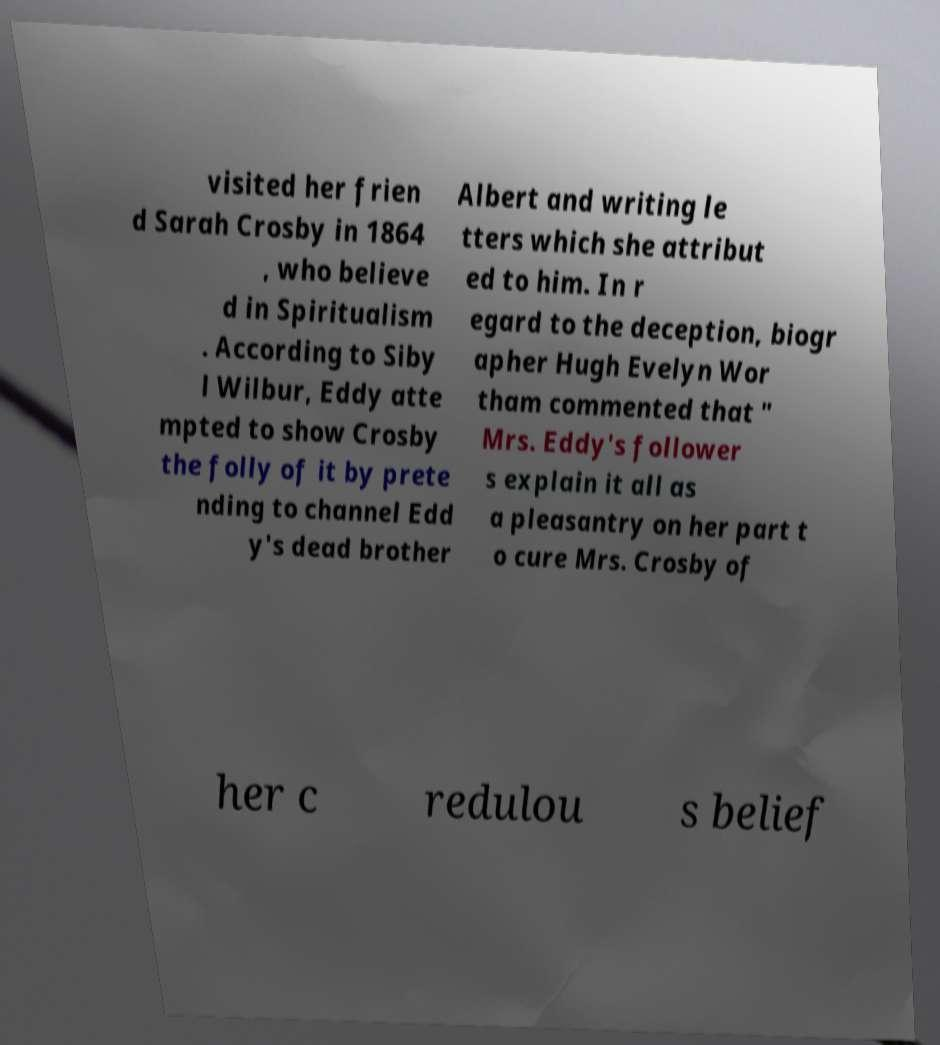What messages or text are displayed in this image? I need them in a readable, typed format. visited her frien d Sarah Crosby in 1864 , who believe d in Spiritualism . According to Siby l Wilbur, Eddy atte mpted to show Crosby the folly of it by prete nding to channel Edd y's dead brother Albert and writing le tters which she attribut ed to him. In r egard to the deception, biogr apher Hugh Evelyn Wor tham commented that " Mrs. Eddy's follower s explain it all as a pleasantry on her part t o cure Mrs. Crosby of her c redulou s belief 